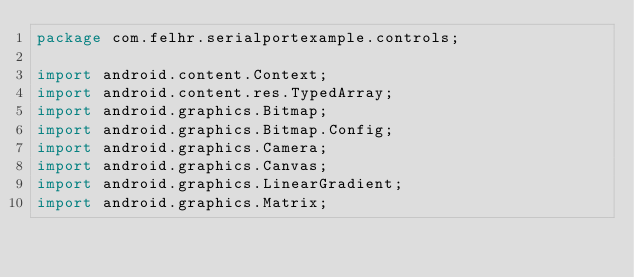Convert code to text. <code><loc_0><loc_0><loc_500><loc_500><_Java_>package com.felhr.serialportexample.controls;

import android.content.Context;
import android.content.res.TypedArray;
import android.graphics.Bitmap;
import android.graphics.Bitmap.Config;
import android.graphics.Camera;
import android.graphics.Canvas;
import android.graphics.LinearGradient;
import android.graphics.Matrix;</code> 